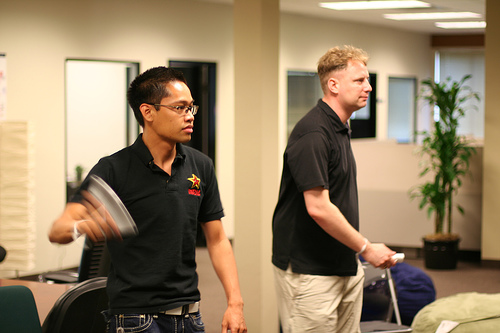What kind of relationship do the individuals in the image likely share? The individuals in the image seem to share a friendly and relaxed association, possibly colleagues or friends enjoying a gaming break together. Can you mention an activity they appear to be enjoying together? They are engaged in playing a video game with Wii controllers, indicating a shared interest in gaming for recreation. 